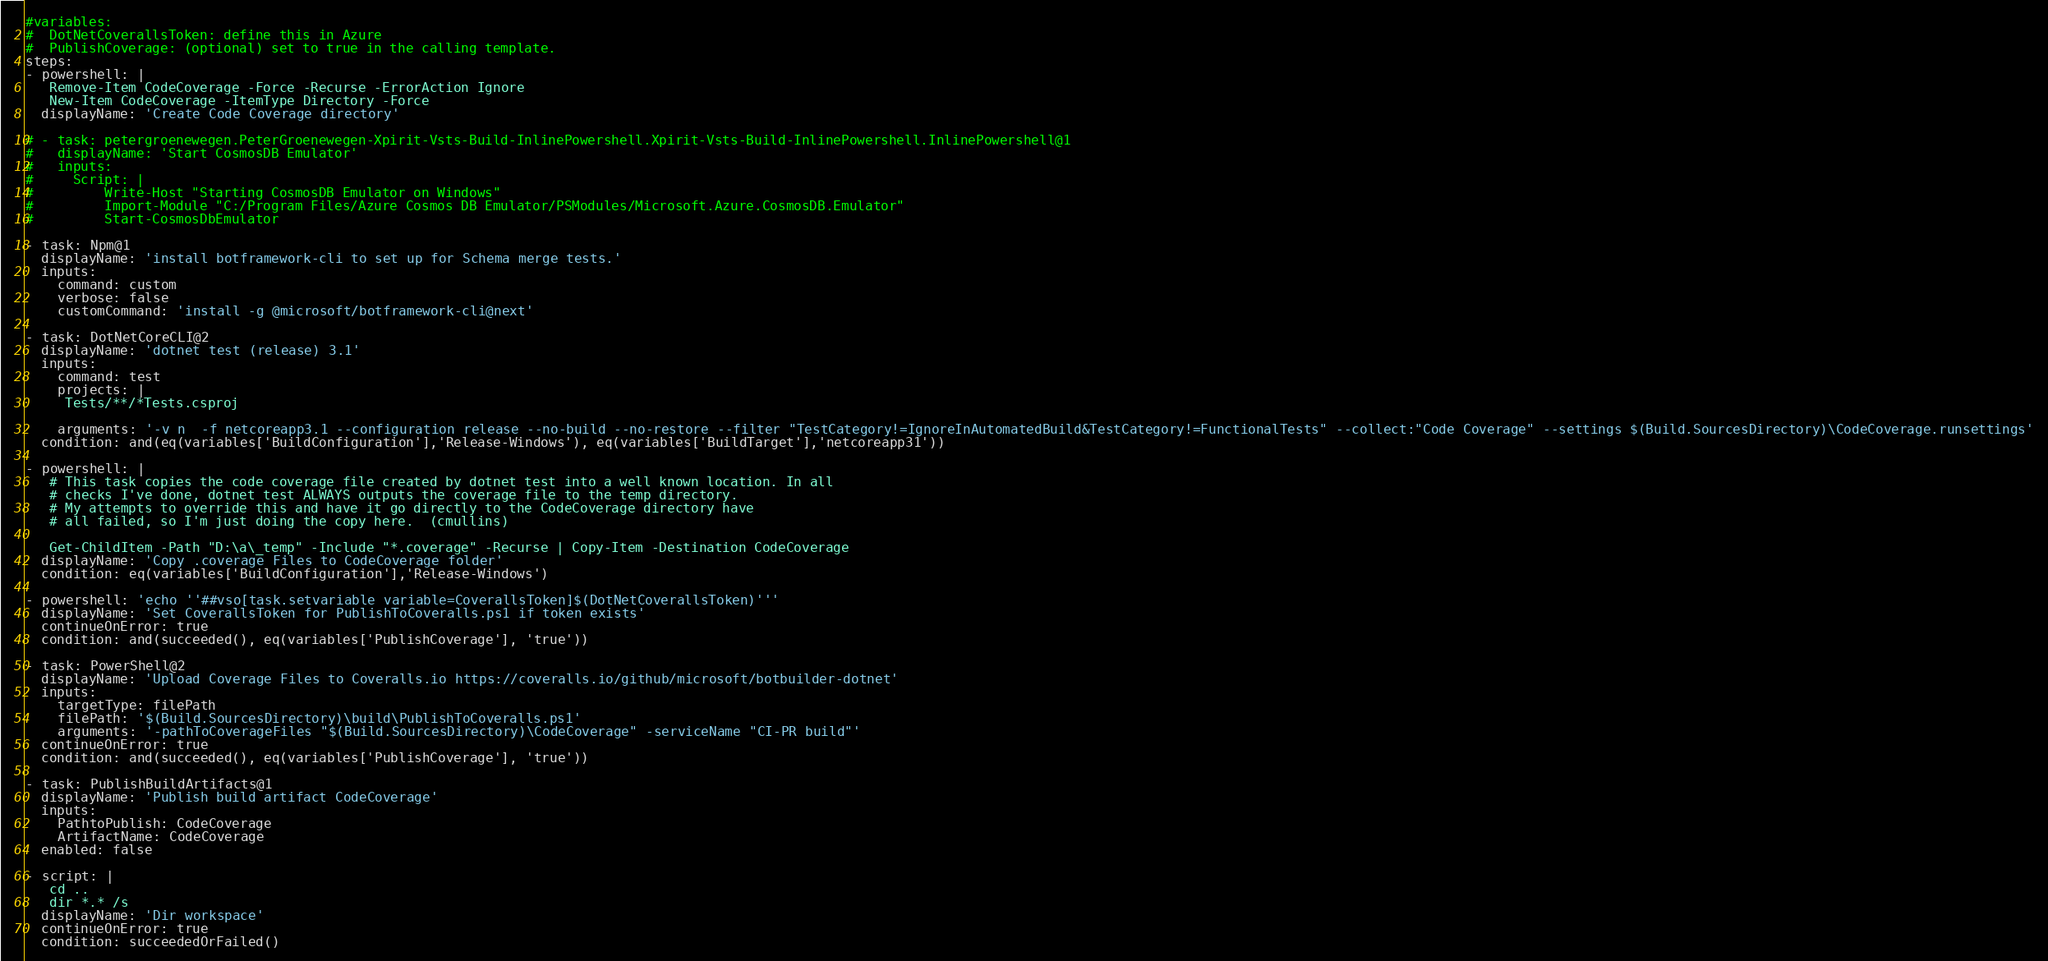<code> <loc_0><loc_0><loc_500><loc_500><_YAML_>#variables:
#  DotNetCoverallsToken: define this in Azure
#  PublishCoverage: (optional) set to true in the calling template.
steps:
- powershell: |
   Remove-Item CodeCoverage -Force -Recurse -ErrorAction Ignore
   New-Item CodeCoverage -ItemType Directory -Force
  displayName: 'Create Code Coverage directory'

# - task: petergroenewegen.PeterGroenewegen-Xpirit-Vsts-Build-InlinePowershell.Xpirit-Vsts-Build-InlinePowershell.InlinePowershell@1
#   displayName: 'Start CosmosDB Emulator'
#   inputs:
#     Script: |
#         Write-Host "Starting CosmosDB Emulator on Windows"
#         Import-Module "C:/Program Files/Azure Cosmos DB Emulator/PSModules/Microsoft.Azure.CosmosDB.Emulator"
#         Start-CosmosDbEmulator

- task: Npm@1
  displayName: 'install botframework-cli to set up for Schema merge tests.'
  inputs:
    command: custom
    verbose: false
    customCommand: 'install -g @microsoft/botframework-cli@next'

- task: DotNetCoreCLI@2
  displayName: 'dotnet test (release) 3.1'
  inputs:
    command: test
    projects: |
     Tests/**/*Tests.csproj

    arguments: '-v n  -f netcoreapp3.1 --configuration release --no-build --no-restore --filter "TestCategory!=IgnoreInAutomatedBuild&TestCategory!=FunctionalTests" --collect:"Code Coverage" --settings $(Build.SourcesDirectory)\CodeCoverage.runsettings'
  condition: and(eq(variables['BuildConfiguration'],'Release-Windows'), eq(variables['BuildTarget'],'netcoreapp31'))

- powershell: |
   # This task copies the code coverage file created by dotnet test into a well known location. In all
   # checks I've done, dotnet test ALWAYS outputs the coverage file to the temp directory. 
   # My attempts to override this and have it go directly to the CodeCoverage directory have
   # all failed, so I'm just doing the copy here.  (cmullins)
   
   Get-ChildItem -Path "D:\a\_temp" -Include "*.coverage" -Recurse | Copy-Item -Destination CodeCoverage
  displayName: 'Copy .coverage Files to CodeCoverage folder'
  condition: eq(variables['BuildConfiguration'],'Release-Windows')

- powershell: 'echo ''##vso[task.setvariable variable=CoverallsToken]$(DotNetCoverallsToken)'''
  displayName: 'Set CoverallsToken for PublishToCoveralls.ps1 if token exists'
  continueOnError: true
  condition: and(succeeded(), eq(variables['PublishCoverage'], 'true'))

- task: PowerShell@2
  displayName: 'Upload Coverage Files to Coveralls.io https://coveralls.io/github/microsoft/botbuilder-dotnet'
  inputs:
    targetType: filePath
    filePath: '$(Build.SourcesDirectory)\build\PublishToCoveralls.ps1'
    arguments: '-pathToCoverageFiles "$(Build.SourcesDirectory)\CodeCoverage" -serviceName "CI-PR build"'
  continueOnError: true
  condition: and(succeeded(), eq(variables['PublishCoverage'], 'true'))

- task: PublishBuildArtifacts@1
  displayName: 'Publish build artifact CodeCoverage'
  inputs:
    PathtoPublish: CodeCoverage
    ArtifactName: CodeCoverage
  enabled: false

- script: |
   cd ..
   dir *.* /s
  displayName: 'Dir workspace'
  continueOnError: true
  condition: succeededOrFailed()
</code> 